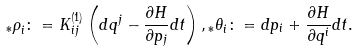<formula> <loc_0><loc_0><loc_500><loc_500>{ _ { * } \rho } _ { i } \colon = K ^ { ( 1 ) } _ { i j } \left ( d q ^ { j } - \frac { \partial H } { \partial p _ { j } } d t \right ) , { _ { * } \theta } _ { i } \colon = d p _ { i } + \frac { \partial H } { \partial q ^ { i } } d t .</formula> 